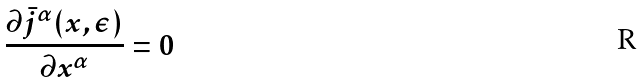<formula> <loc_0><loc_0><loc_500><loc_500>\frac { \partial \bar { j } ^ { \alpha } ( x , \epsilon ) } { \partial x ^ { \alpha } } = 0</formula> 